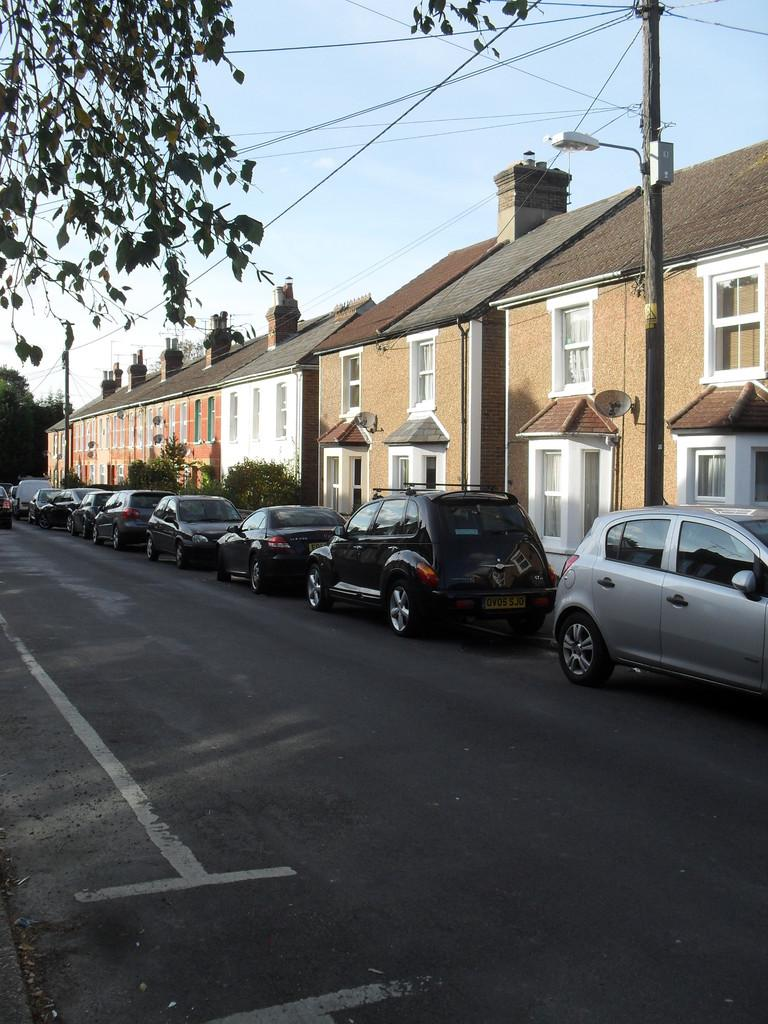What is visible at the top of the image? The sky is visible at the top of the image. What type of vegetation can be seen in the image? There are trees in the image. What structure is present in the image? There is a pole and a light in the image. What type of buildings are visible in the image? There are buildings with windows in the image. What mode of transportation can be seen on the right side of the image? Cars are present on the road on the right side of the image. What type of farm animals can be seen sleeping on the beds in the image? There is no farm or beds present in the image; it features a sky, trees, a pole and a light, buildings, and cars on a road. What type of dinner is being served in the image? There is no dinner or food present in the image. 